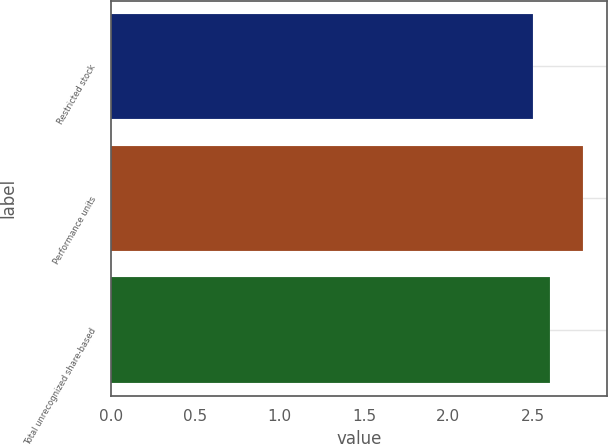Convert chart to OTSL. <chart><loc_0><loc_0><loc_500><loc_500><bar_chart><fcel>Restricted stock<fcel>Performance units<fcel>Total unrecognized share-based<nl><fcel>2.5<fcel>2.8<fcel>2.6<nl></chart> 